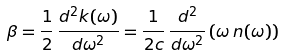<formula> <loc_0><loc_0><loc_500><loc_500>\beta = \frac { 1 } { 2 } \, \frac { d ^ { 2 } k ( \omega ) } { d \omega ^ { 2 } } = \frac { 1 } { 2 c } \, \frac { d ^ { 2 } } { d \omega ^ { 2 } } \left ( \omega \, n ( \omega ) \right )</formula> 